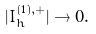<formula> <loc_0><loc_0><loc_500><loc_500>| I _ { h } ^ { ( 1 ) , + } | \to 0 .</formula> 